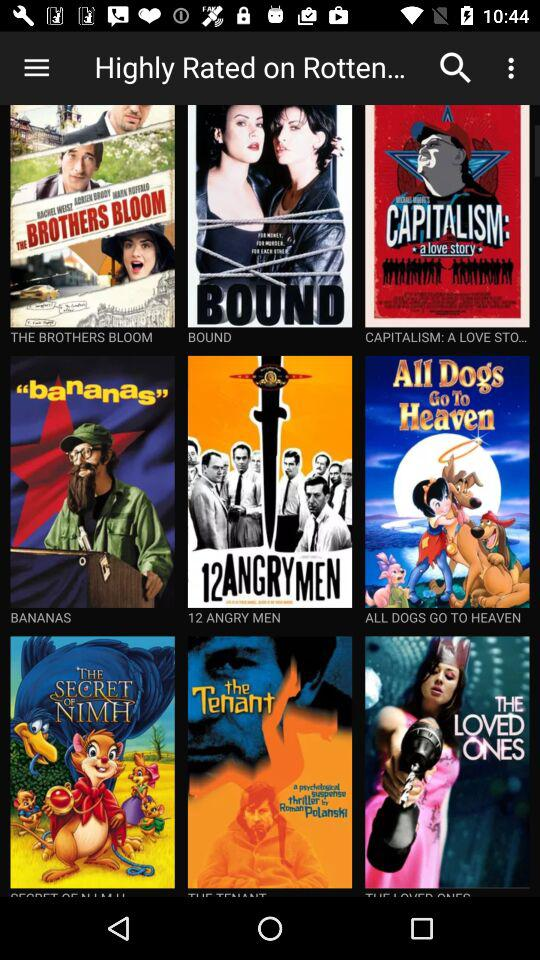What are the names of the different movies shown on the screen? The names are "THE BROTHERS BLOOM", "BOUND", "CAPITALISM: A LOVE STO...", "BANANAS", "12 ANGRY MEN", "ALL DOGS GO TO HEAVEN", "THE SECRET OF NIMH", "the Tenant" and "THE LOVED ONES". 